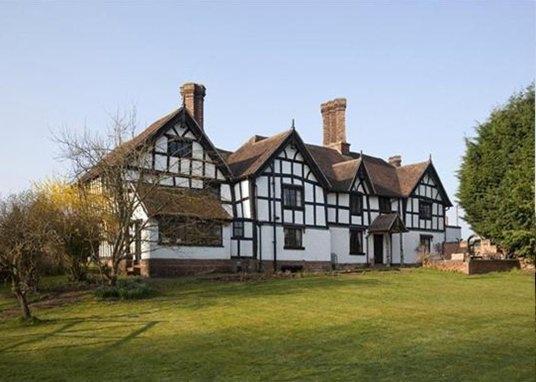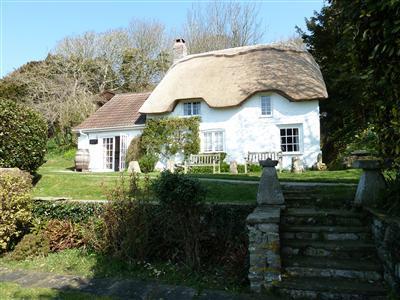The first image is the image on the left, the second image is the image on the right. Evaluate the accuracy of this statement regarding the images: "A short stone wall bounds the house in the image on the left.". Is it true? Answer yes or no. No. The first image is the image on the left, the second image is the image on the right. Examine the images to the left and right. Is the description "In each image, a building has a gray roof that curves around items like windows or doors instead of just overhanging them." accurate? Answer yes or no. No. 